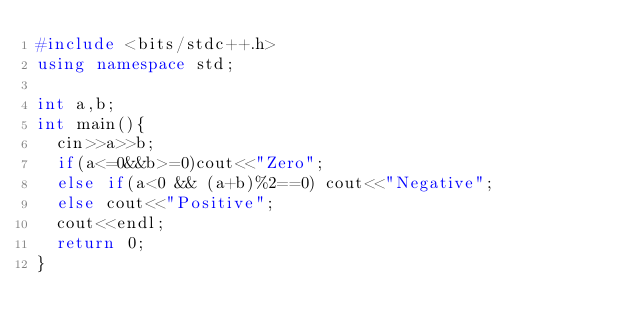Convert code to text. <code><loc_0><loc_0><loc_500><loc_500><_C++_>#include <bits/stdc++.h>
using namespace std;

int a,b;
int main(){
  cin>>a>>b;
  if(a<=0&&b>=0)cout<<"Zero";
  else if(a<0 && (a+b)%2==0) cout<<"Negative";
  else cout<<"Positive";
  cout<<endl;
  return 0;
}
</code> 